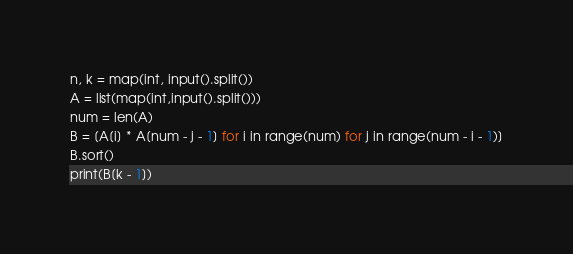<code> <loc_0><loc_0><loc_500><loc_500><_Python_>n, k = map(int, input().split())
A = list(map(int,input().split()))
num = len(A)
B = [A[i] * A[num - j - 1] for i in range(num) for j in range(num - i - 1)]
B.sort()
print(B[k - 1])</code> 